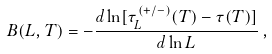Convert formula to latex. <formula><loc_0><loc_0><loc_500><loc_500>B ( L , T ) = - \frac { d \ln [ \tau ^ { ( + / - ) } _ { L } ( T ) - \tau ( T ) ] } { d \ln L } \, ,</formula> 